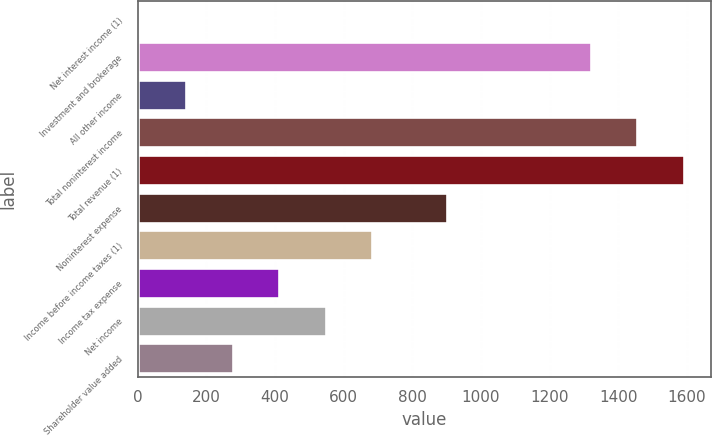Convert chart to OTSL. <chart><loc_0><loc_0><loc_500><loc_500><bar_chart><fcel>Net interest income (1)<fcel>Investment and brokerage<fcel>All other income<fcel>Total noninterest income<fcel>Total revenue (1)<fcel>Noninterest expense<fcel>Income before income taxes (1)<fcel>Income tax expense<fcel>Net income<fcel>Shareholder value added<nl><fcel>6<fcel>1321<fcel>141.3<fcel>1456.3<fcel>1591.6<fcel>902<fcel>682.5<fcel>411.9<fcel>547.2<fcel>276.6<nl></chart> 